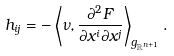<formula> <loc_0><loc_0><loc_500><loc_500>h _ { i j } = - \left \langle \nu , \frac { \partial ^ { 2 } F } { \partial x ^ { i } \partial x ^ { j } } \right \rangle _ { g _ { \mathbb { R } ^ { n + 1 } } } .</formula> 